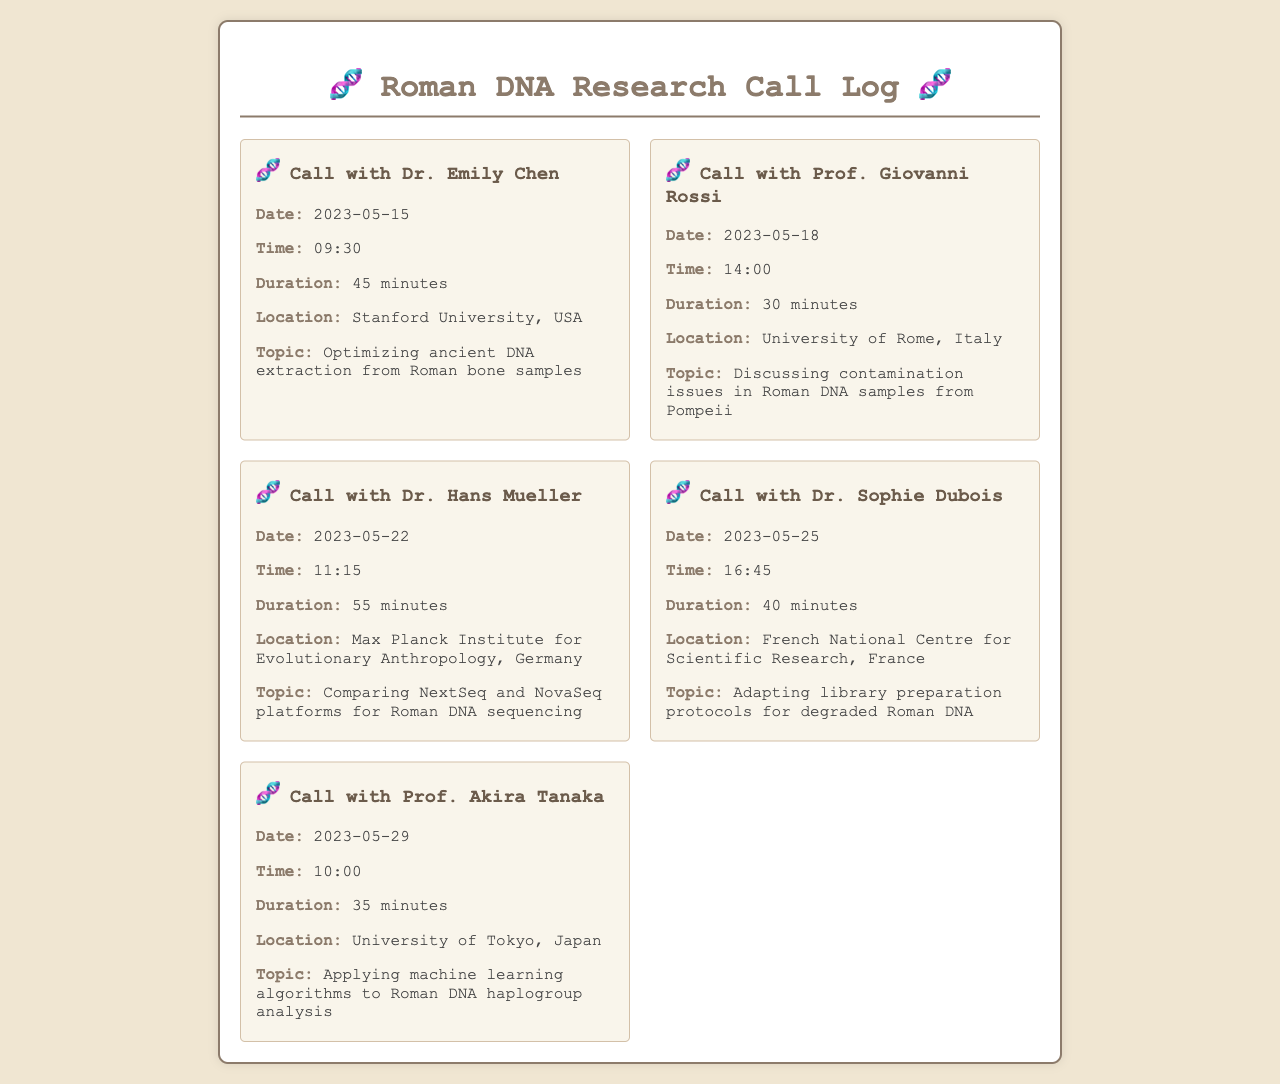What was the duration of the call with Dr. Emily Chen? The duration of the call with Dr. Emily Chen is specified in the document as 45 minutes.
Answer: 45 minutes What was the topic of discussion with Prof. Giovanni Rossi? The document states that the topic discussed with Prof. Giovanni Rossi was contamination issues in Roman DNA samples from Pompeii.
Answer: Contamination issues in Roman DNA samples from Pompeii When did the call with Dr. Hans Mueller take place? The date of the call with Dr. Hans Mueller is given in the document as May 22, 2023.
Answer: May 22, 2023 Who was the caller from the University of Tokyo, Japan? According to the document, the caller from the University of Tokyo, Japan, was Prof. Akira Tanaka.
Answer: Prof. Akira Tanaka What is the common theme in the calls listed? The common theme in the calls is the analysis and techniques related to Roman DNA research.
Answer: Analysis and techniques related to Roman DNA research How long was the call with Dr. Sophie Dubois? The document states that the duration of the call with Dr. Sophie Dubois was 40 minutes.
Answer: 40 minutes What university is associated with the call on May 29, 2023? The document lists the University of Tokyo, Japan, as the university associated with the call on May 29, 2023.
Answer: University of Tokyo, Japan Which two individuals were involved in discussions about DNA sequencing platforms? The document specifies that Dr. Hans Mueller and another unmentioned individual discussed comparing NextSeq and NovaSeq platforms for Roman DNA sequencing.
Answer: Dr. Hans Mueller How many calls are documented? The document contains a total of five calls which are detailed in the log.
Answer: Five calls 